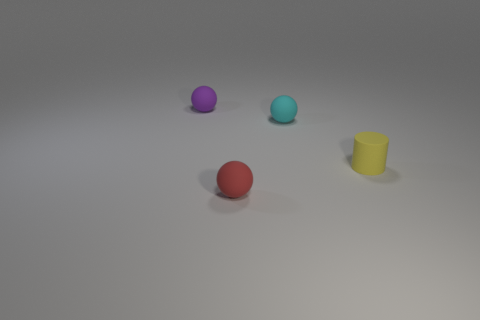Add 4 cyan balls. How many objects exist? 8 Subtract all cylinders. How many objects are left? 3 Add 1 yellow cylinders. How many yellow cylinders are left? 2 Add 2 red objects. How many red objects exist? 3 Subtract 0 yellow blocks. How many objects are left? 4 Subtract all cyan rubber cylinders. Subtract all purple matte things. How many objects are left? 3 